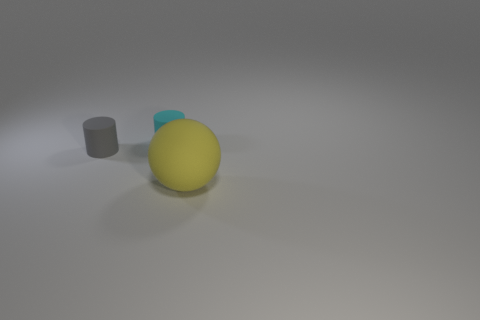Is there anything else that is the same size as the ball?
Ensure brevity in your answer.  No. What is the material of the other thing that is the same size as the cyan matte thing?
Your answer should be compact. Rubber. What number of small objects are either spheres or rubber cylinders?
Offer a very short reply. 2. Are there any large red shiny objects?
Give a very brief answer. No. The gray object that is the same material as the yellow ball is what size?
Provide a succinct answer. Small. How many other things are made of the same material as the yellow object?
Provide a short and direct response. 2. How many matte things are in front of the cyan object and to the right of the small gray rubber cylinder?
Keep it short and to the point. 1. What color is the large matte object?
Your answer should be compact. Yellow. What is the shape of the small object in front of the cyan matte thing that is right of the gray cylinder?
Your response must be concise. Cylinder. There is another tiny thing that is made of the same material as the small cyan object; what shape is it?
Keep it short and to the point. Cylinder. 